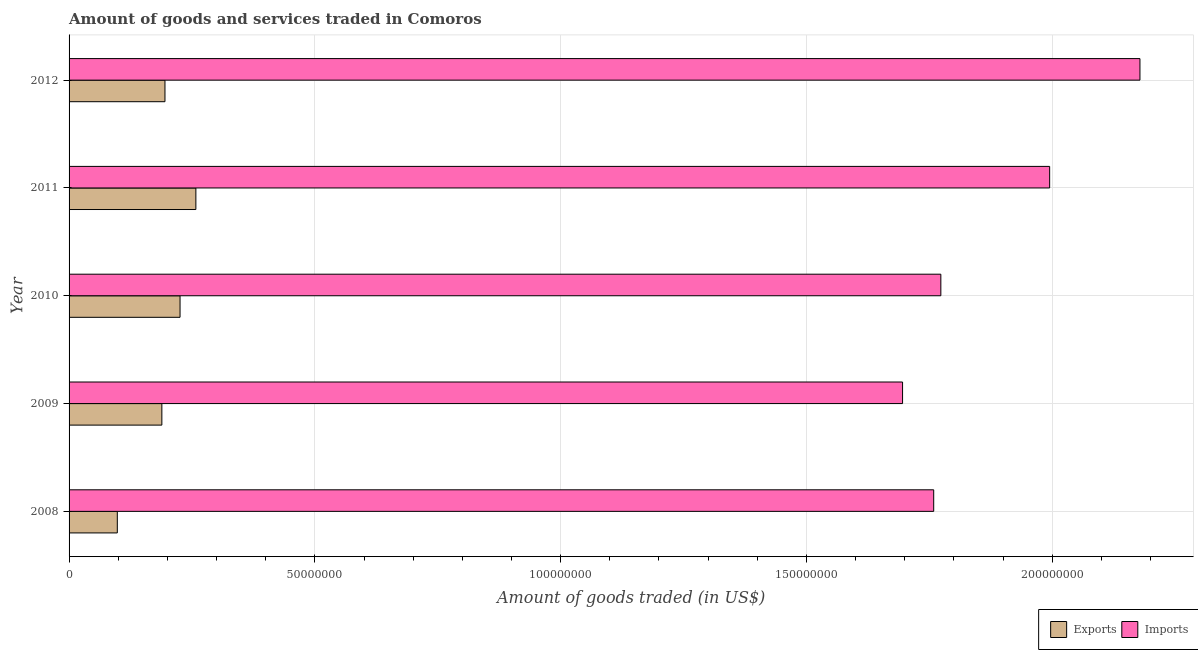How many groups of bars are there?
Offer a very short reply. 5. How many bars are there on the 4th tick from the top?
Offer a very short reply. 2. What is the label of the 2nd group of bars from the top?
Provide a short and direct response. 2011. In how many cases, is the number of bars for a given year not equal to the number of legend labels?
Your response must be concise. 0. What is the amount of goods exported in 2009?
Your response must be concise. 1.89e+07. Across all years, what is the maximum amount of goods imported?
Offer a terse response. 2.18e+08. Across all years, what is the minimum amount of goods imported?
Your response must be concise. 1.70e+08. In which year was the amount of goods exported minimum?
Make the answer very short. 2008. What is the total amount of goods exported in the graph?
Your answer should be very brief. 9.66e+07. What is the difference between the amount of goods imported in 2010 and that in 2011?
Make the answer very short. -2.21e+07. What is the difference between the amount of goods imported in 2008 and the amount of goods exported in 2011?
Offer a very short reply. 1.50e+08. What is the average amount of goods exported per year?
Make the answer very short. 1.93e+07. In the year 2011, what is the difference between the amount of goods exported and amount of goods imported?
Offer a terse response. -1.74e+08. What is the ratio of the amount of goods exported in 2009 to that in 2011?
Keep it short and to the point. 0.73. Is the amount of goods imported in 2008 less than that in 2010?
Offer a very short reply. Yes. Is the difference between the amount of goods imported in 2009 and 2010 greater than the difference between the amount of goods exported in 2009 and 2010?
Give a very brief answer. No. What is the difference between the highest and the second highest amount of goods imported?
Provide a short and direct response. 1.84e+07. What is the difference between the highest and the lowest amount of goods imported?
Make the answer very short. 4.83e+07. In how many years, is the amount of goods exported greater than the average amount of goods exported taken over all years?
Your response must be concise. 3. Is the sum of the amount of goods imported in 2010 and 2011 greater than the maximum amount of goods exported across all years?
Your answer should be compact. Yes. What does the 1st bar from the top in 2011 represents?
Provide a short and direct response. Imports. What does the 2nd bar from the bottom in 2009 represents?
Your response must be concise. Imports. What is the difference between two consecutive major ticks on the X-axis?
Offer a terse response. 5.00e+07. Are the values on the major ticks of X-axis written in scientific E-notation?
Your answer should be compact. No. Where does the legend appear in the graph?
Your response must be concise. Bottom right. How many legend labels are there?
Provide a short and direct response. 2. What is the title of the graph?
Provide a succinct answer. Amount of goods and services traded in Comoros. Does "Lower secondary rate" appear as one of the legend labels in the graph?
Your answer should be very brief. No. What is the label or title of the X-axis?
Offer a very short reply. Amount of goods traded (in US$). What is the Amount of goods traded (in US$) of Exports in 2008?
Your answer should be very brief. 9.81e+06. What is the Amount of goods traded (in US$) of Imports in 2008?
Your answer should be compact. 1.76e+08. What is the Amount of goods traded (in US$) of Exports in 2009?
Provide a short and direct response. 1.89e+07. What is the Amount of goods traded (in US$) of Imports in 2009?
Keep it short and to the point. 1.70e+08. What is the Amount of goods traded (in US$) in Exports in 2010?
Keep it short and to the point. 2.26e+07. What is the Amount of goods traded (in US$) in Imports in 2010?
Provide a succinct answer. 1.77e+08. What is the Amount of goods traded (in US$) of Exports in 2011?
Offer a terse response. 2.58e+07. What is the Amount of goods traded (in US$) in Imports in 2011?
Your response must be concise. 1.99e+08. What is the Amount of goods traded (in US$) of Exports in 2012?
Give a very brief answer. 1.95e+07. What is the Amount of goods traded (in US$) in Imports in 2012?
Your response must be concise. 2.18e+08. Across all years, what is the maximum Amount of goods traded (in US$) of Exports?
Provide a short and direct response. 2.58e+07. Across all years, what is the maximum Amount of goods traded (in US$) of Imports?
Offer a terse response. 2.18e+08. Across all years, what is the minimum Amount of goods traded (in US$) in Exports?
Keep it short and to the point. 9.81e+06. Across all years, what is the minimum Amount of goods traded (in US$) in Imports?
Your answer should be compact. 1.70e+08. What is the total Amount of goods traded (in US$) in Exports in the graph?
Make the answer very short. 9.66e+07. What is the total Amount of goods traded (in US$) of Imports in the graph?
Provide a short and direct response. 9.40e+08. What is the difference between the Amount of goods traded (in US$) of Exports in 2008 and that in 2009?
Provide a succinct answer. -9.06e+06. What is the difference between the Amount of goods traded (in US$) in Imports in 2008 and that in 2009?
Offer a very short reply. 6.33e+06. What is the difference between the Amount of goods traded (in US$) of Exports in 2008 and that in 2010?
Make the answer very short. -1.28e+07. What is the difference between the Amount of goods traded (in US$) in Imports in 2008 and that in 2010?
Ensure brevity in your answer.  -1.45e+06. What is the difference between the Amount of goods traded (in US$) in Exports in 2008 and that in 2011?
Give a very brief answer. -1.60e+07. What is the difference between the Amount of goods traded (in US$) of Imports in 2008 and that in 2011?
Make the answer very short. -2.36e+07. What is the difference between the Amount of goods traded (in US$) in Exports in 2008 and that in 2012?
Provide a short and direct response. -9.69e+06. What is the difference between the Amount of goods traded (in US$) in Imports in 2008 and that in 2012?
Provide a short and direct response. -4.20e+07. What is the difference between the Amount of goods traded (in US$) of Exports in 2009 and that in 2010?
Give a very brief answer. -3.70e+06. What is the difference between the Amount of goods traded (in US$) in Imports in 2009 and that in 2010?
Offer a very short reply. -7.79e+06. What is the difference between the Amount of goods traded (in US$) in Exports in 2009 and that in 2011?
Provide a succinct answer. -6.92e+06. What is the difference between the Amount of goods traded (in US$) in Imports in 2009 and that in 2011?
Ensure brevity in your answer.  -2.99e+07. What is the difference between the Amount of goods traded (in US$) of Exports in 2009 and that in 2012?
Make the answer very short. -6.33e+05. What is the difference between the Amount of goods traded (in US$) of Imports in 2009 and that in 2012?
Your answer should be compact. -4.83e+07. What is the difference between the Amount of goods traded (in US$) in Exports in 2010 and that in 2011?
Your answer should be compact. -3.22e+06. What is the difference between the Amount of goods traded (in US$) of Imports in 2010 and that in 2011?
Your response must be concise. -2.21e+07. What is the difference between the Amount of goods traded (in US$) of Exports in 2010 and that in 2012?
Give a very brief answer. 3.07e+06. What is the difference between the Amount of goods traded (in US$) of Imports in 2010 and that in 2012?
Ensure brevity in your answer.  -4.05e+07. What is the difference between the Amount of goods traded (in US$) of Exports in 2011 and that in 2012?
Provide a short and direct response. 6.29e+06. What is the difference between the Amount of goods traded (in US$) in Imports in 2011 and that in 2012?
Ensure brevity in your answer.  -1.84e+07. What is the difference between the Amount of goods traded (in US$) in Exports in 2008 and the Amount of goods traded (in US$) in Imports in 2009?
Your answer should be compact. -1.60e+08. What is the difference between the Amount of goods traded (in US$) in Exports in 2008 and the Amount of goods traded (in US$) in Imports in 2010?
Give a very brief answer. -1.68e+08. What is the difference between the Amount of goods traded (in US$) in Exports in 2008 and the Amount of goods traded (in US$) in Imports in 2011?
Your answer should be compact. -1.90e+08. What is the difference between the Amount of goods traded (in US$) in Exports in 2008 and the Amount of goods traded (in US$) in Imports in 2012?
Your answer should be compact. -2.08e+08. What is the difference between the Amount of goods traded (in US$) of Exports in 2009 and the Amount of goods traded (in US$) of Imports in 2010?
Offer a terse response. -1.58e+08. What is the difference between the Amount of goods traded (in US$) in Exports in 2009 and the Amount of goods traded (in US$) in Imports in 2011?
Make the answer very short. -1.81e+08. What is the difference between the Amount of goods traded (in US$) in Exports in 2009 and the Amount of goods traded (in US$) in Imports in 2012?
Offer a terse response. -1.99e+08. What is the difference between the Amount of goods traded (in US$) of Exports in 2010 and the Amount of goods traded (in US$) of Imports in 2011?
Ensure brevity in your answer.  -1.77e+08. What is the difference between the Amount of goods traded (in US$) in Exports in 2010 and the Amount of goods traded (in US$) in Imports in 2012?
Offer a very short reply. -1.95e+08. What is the difference between the Amount of goods traded (in US$) of Exports in 2011 and the Amount of goods traded (in US$) of Imports in 2012?
Make the answer very short. -1.92e+08. What is the average Amount of goods traded (in US$) in Exports per year?
Your answer should be very brief. 1.93e+07. What is the average Amount of goods traded (in US$) in Imports per year?
Ensure brevity in your answer.  1.88e+08. In the year 2008, what is the difference between the Amount of goods traded (in US$) in Exports and Amount of goods traded (in US$) in Imports?
Provide a succinct answer. -1.66e+08. In the year 2009, what is the difference between the Amount of goods traded (in US$) in Exports and Amount of goods traded (in US$) in Imports?
Provide a succinct answer. -1.51e+08. In the year 2010, what is the difference between the Amount of goods traded (in US$) in Exports and Amount of goods traded (in US$) in Imports?
Give a very brief answer. -1.55e+08. In the year 2011, what is the difference between the Amount of goods traded (in US$) in Exports and Amount of goods traded (in US$) in Imports?
Keep it short and to the point. -1.74e+08. In the year 2012, what is the difference between the Amount of goods traded (in US$) in Exports and Amount of goods traded (in US$) in Imports?
Offer a very short reply. -1.98e+08. What is the ratio of the Amount of goods traded (in US$) in Exports in 2008 to that in 2009?
Your answer should be very brief. 0.52. What is the ratio of the Amount of goods traded (in US$) of Imports in 2008 to that in 2009?
Your answer should be very brief. 1.04. What is the ratio of the Amount of goods traded (in US$) in Exports in 2008 to that in 2010?
Offer a very short reply. 0.43. What is the ratio of the Amount of goods traded (in US$) in Exports in 2008 to that in 2011?
Your response must be concise. 0.38. What is the ratio of the Amount of goods traded (in US$) in Imports in 2008 to that in 2011?
Offer a very short reply. 0.88. What is the ratio of the Amount of goods traded (in US$) of Exports in 2008 to that in 2012?
Give a very brief answer. 0.5. What is the ratio of the Amount of goods traded (in US$) in Imports in 2008 to that in 2012?
Give a very brief answer. 0.81. What is the ratio of the Amount of goods traded (in US$) in Exports in 2009 to that in 2010?
Provide a succinct answer. 0.84. What is the ratio of the Amount of goods traded (in US$) of Imports in 2009 to that in 2010?
Offer a terse response. 0.96. What is the ratio of the Amount of goods traded (in US$) in Exports in 2009 to that in 2011?
Ensure brevity in your answer.  0.73. What is the ratio of the Amount of goods traded (in US$) of Exports in 2009 to that in 2012?
Offer a terse response. 0.97. What is the ratio of the Amount of goods traded (in US$) of Imports in 2009 to that in 2012?
Your answer should be compact. 0.78. What is the ratio of the Amount of goods traded (in US$) in Exports in 2010 to that in 2011?
Make the answer very short. 0.88. What is the ratio of the Amount of goods traded (in US$) of Imports in 2010 to that in 2011?
Give a very brief answer. 0.89. What is the ratio of the Amount of goods traded (in US$) in Exports in 2010 to that in 2012?
Offer a terse response. 1.16. What is the ratio of the Amount of goods traded (in US$) of Imports in 2010 to that in 2012?
Your response must be concise. 0.81. What is the ratio of the Amount of goods traded (in US$) in Exports in 2011 to that in 2012?
Provide a short and direct response. 1.32. What is the ratio of the Amount of goods traded (in US$) of Imports in 2011 to that in 2012?
Your answer should be compact. 0.92. What is the difference between the highest and the second highest Amount of goods traded (in US$) in Exports?
Keep it short and to the point. 3.22e+06. What is the difference between the highest and the second highest Amount of goods traded (in US$) in Imports?
Offer a very short reply. 1.84e+07. What is the difference between the highest and the lowest Amount of goods traded (in US$) of Exports?
Ensure brevity in your answer.  1.60e+07. What is the difference between the highest and the lowest Amount of goods traded (in US$) of Imports?
Your answer should be compact. 4.83e+07. 